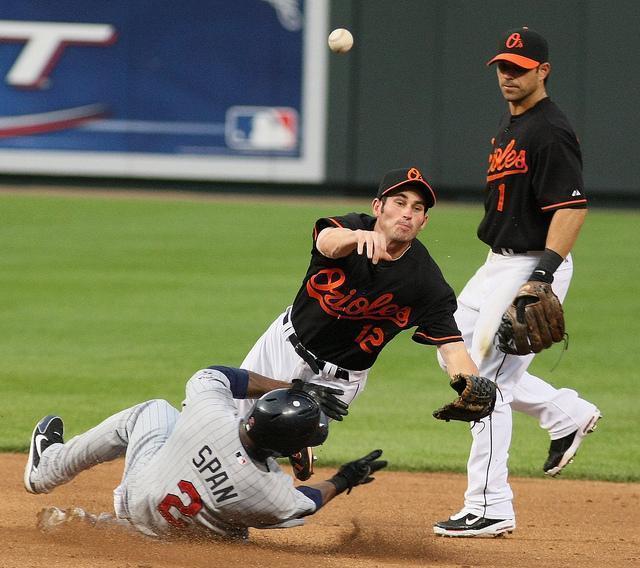How many people are there?
Give a very brief answer. 3. How many baseball gloves are in the photo?
Give a very brief answer. 2. 